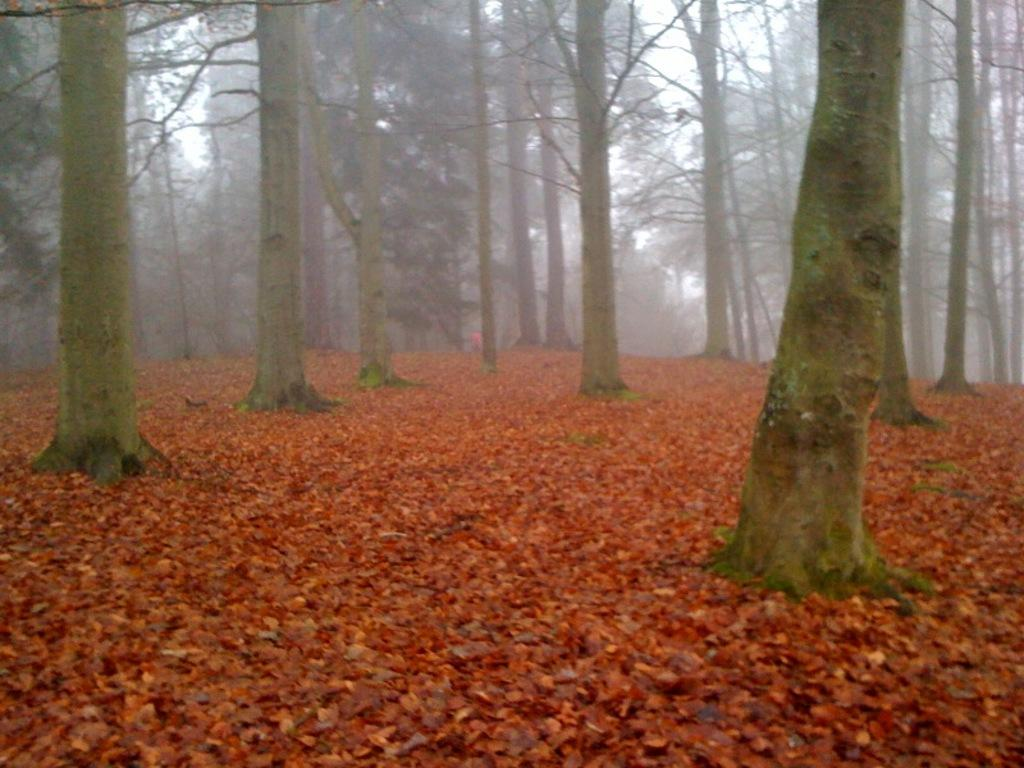What is the main feature of the land in the image? The land in the image is covered with leaves. What can be seen in the background of the image? There are trees in the background of the image. What is the value of the plant in the image? There is no plant present in the image, so it is not possible to determine its value. 